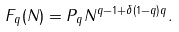<formula> <loc_0><loc_0><loc_500><loc_500>F _ { q } ( N ) = P _ { q } N ^ { q - 1 + \delta ( 1 - q ) q } .</formula> 